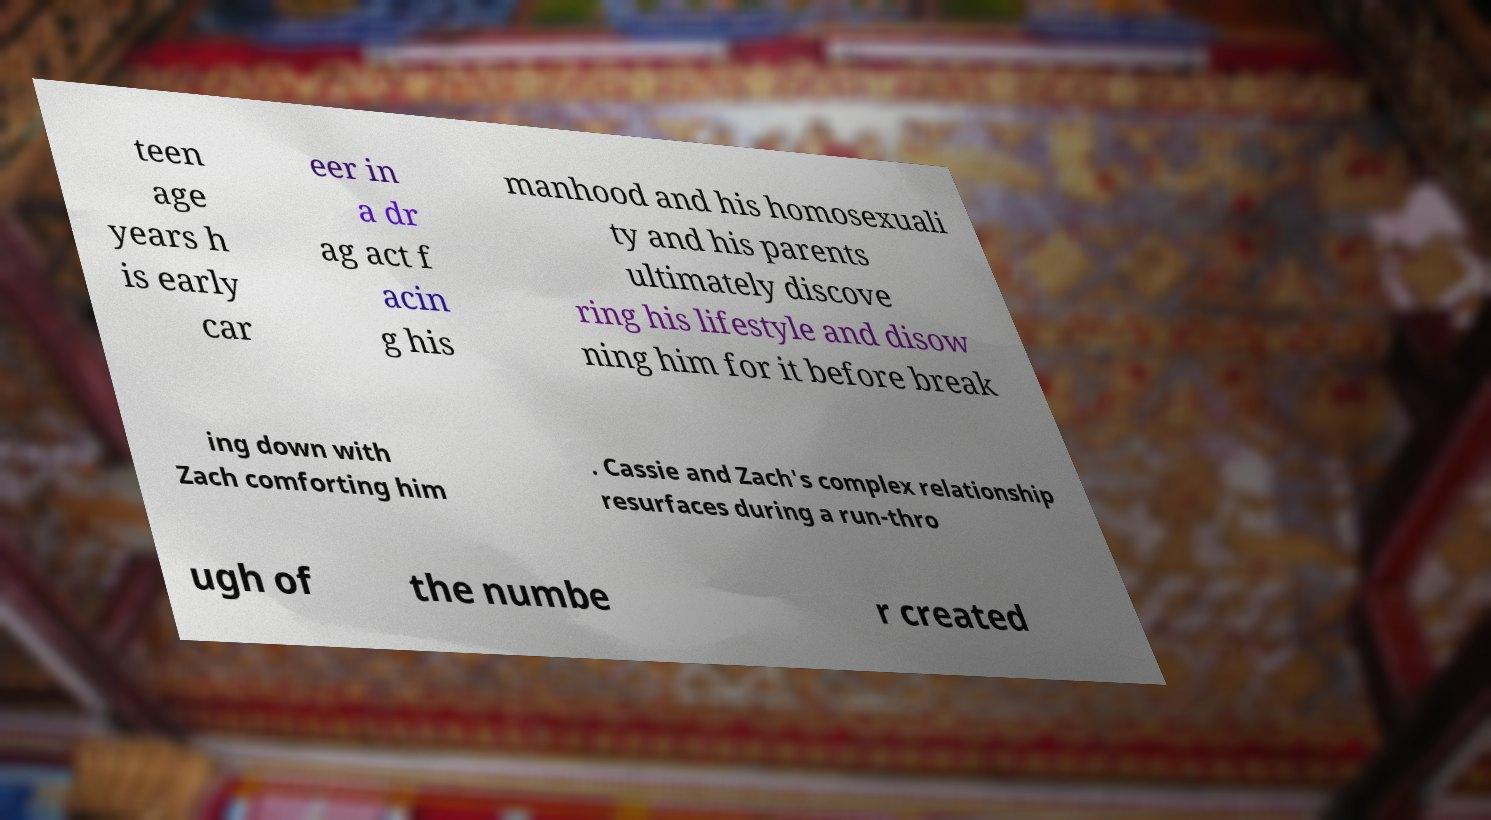What messages or text are displayed in this image? I need them in a readable, typed format. teen age years h is early car eer in a dr ag act f acin g his manhood and his homosexuali ty and his parents ultimately discove ring his lifestyle and disow ning him for it before break ing down with Zach comforting him . Cassie and Zach's complex relationship resurfaces during a run-thro ugh of the numbe r created 